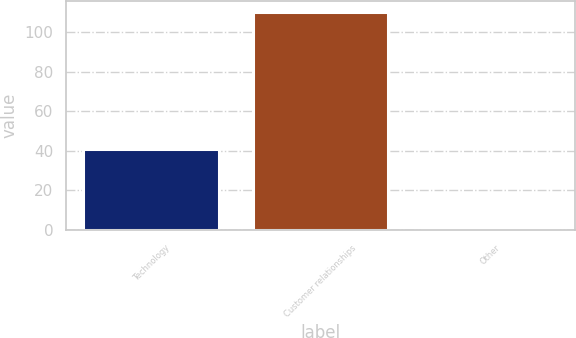<chart> <loc_0><loc_0><loc_500><loc_500><bar_chart><fcel>Technology<fcel>Customer relationships<fcel>Other<nl><fcel>41<fcel>110<fcel>1<nl></chart> 